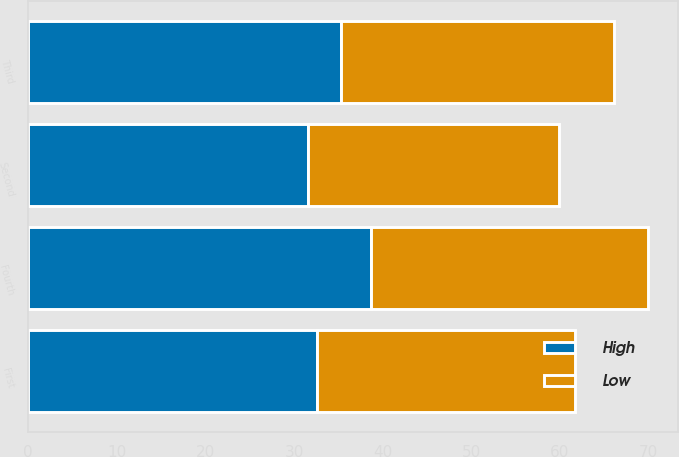Convert chart. <chart><loc_0><loc_0><loc_500><loc_500><stacked_bar_chart><ecel><fcel>First<fcel>Second<fcel>Third<fcel>Fourth<nl><fcel>High<fcel>32.54<fcel>31.61<fcel>35.25<fcel>38.73<nl><fcel>Low<fcel>29.14<fcel>28.27<fcel>30.85<fcel>31.14<nl></chart> 